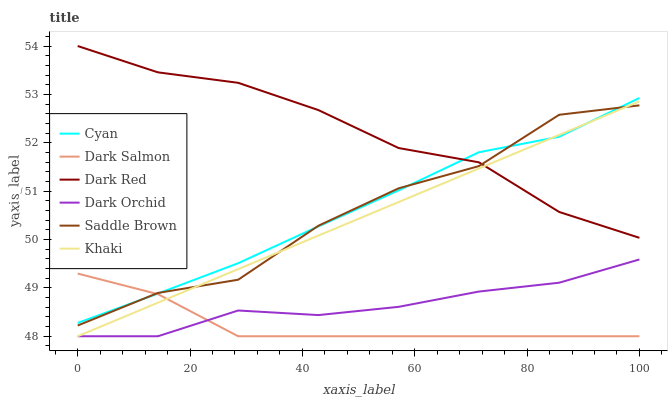Does Dark Salmon have the minimum area under the curve?
Answer yes or no. Yes. Does Dark Red have the maximum area under the curve?
Answer yes or no. Yes. Does Dark Red have the minimum area under the curve?
Answer yes or no. No. Does Dark Salmon have the maximum area under the curve?
Answer yes or no. No. Is Khaki the smoothest?
Answer yes or no. Yes. Is Saddle Brown the roughest?
Answer yes or no. Yes. Is Dark Red the smoothest?
Answer yes or no. No. Is Dark Red the roughest?
Answer yes or no. No. Does Khaki have the lowest value?
Answer yes or no. Yes. Does Dark Red have the lowest value?
Answer yes or no. No. Does Dark Red have the highest value?
Answer yes or no. Yes. Does Dark Salmon have the highest value?
Answer yes or no. No. Is Dark Orchid less than Dark Red?
Answer yes or no. Yes. Is Dark Red greater than Dark Salmon?
Answer yes or no. Yes. Does Dark Salmon intersect Cyan?
Answer yes or no. Yes. Is Dark Salmon less than Cyan?
Answer yes or no. No. Is Dark Salmon greater than Cyan?
Answer yes or no. No. Does Dark Orchid intersect Dark Red?
Answer yes or no. No. 